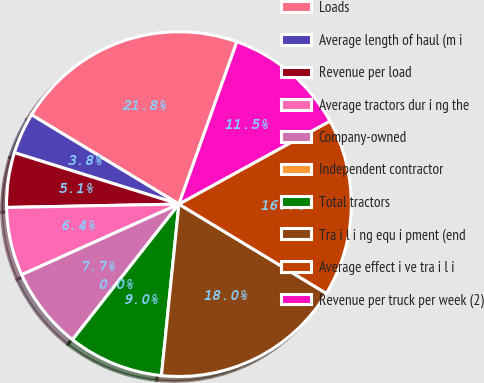<chart> <loc_0><loc_0><loc_500><loc_500><pie_chart><fcel>Loads<fcel>Average length of haul (m i<fcel>Revenue per load<fcel>Average tractors dur i ng the<fcel>Company-owned<fcel>Independent contractor<fcel>Total tractors<fcel>Tra i l i ng equ i pment (end<fcel>Average effect i ve tra i l i<fcel>Revenue per truck per week (2)<nl><fcel>21.79%<fcel>3.85%<fcel>5.13%<fcel>6.41%<fcel>7.69%<fcel>0.0%<fcel>8.97%<fcel>17.95%<fcel>16.67%<fcel>11.54%<nl></chart> 